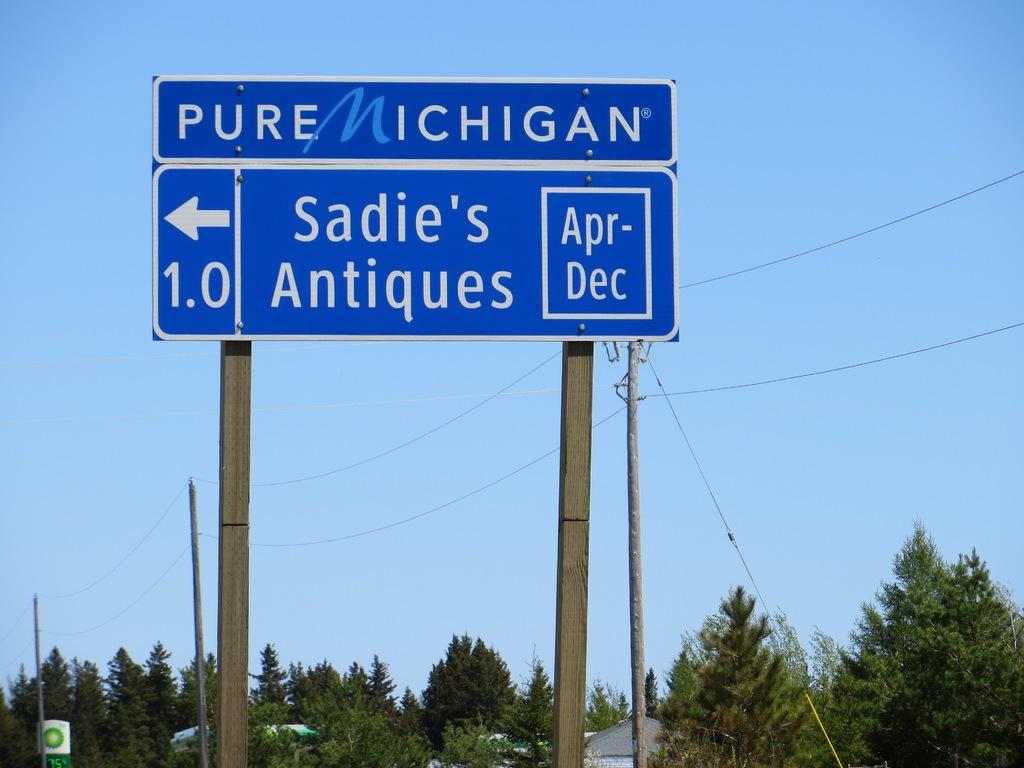<image>
Render a clear and concise summary of the photo. A road sign points to Sadie's Antiques and provides the months it is open. 